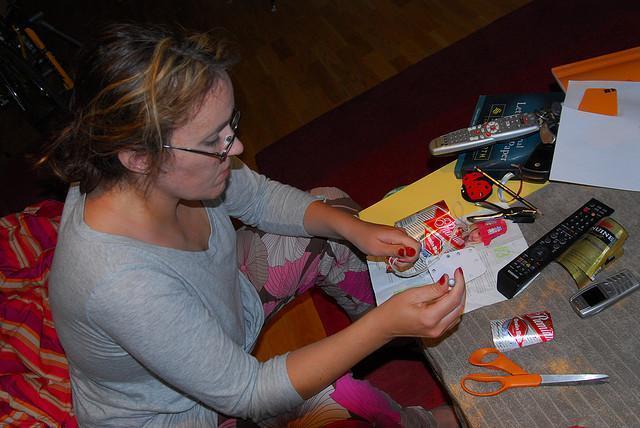Verify the accuracy of this image caption: "The couch is in front of the person.".
Answer yes or no. No. Does the image validate the caption "The couch is opposite to the person."?
Answer yes or no. No. 